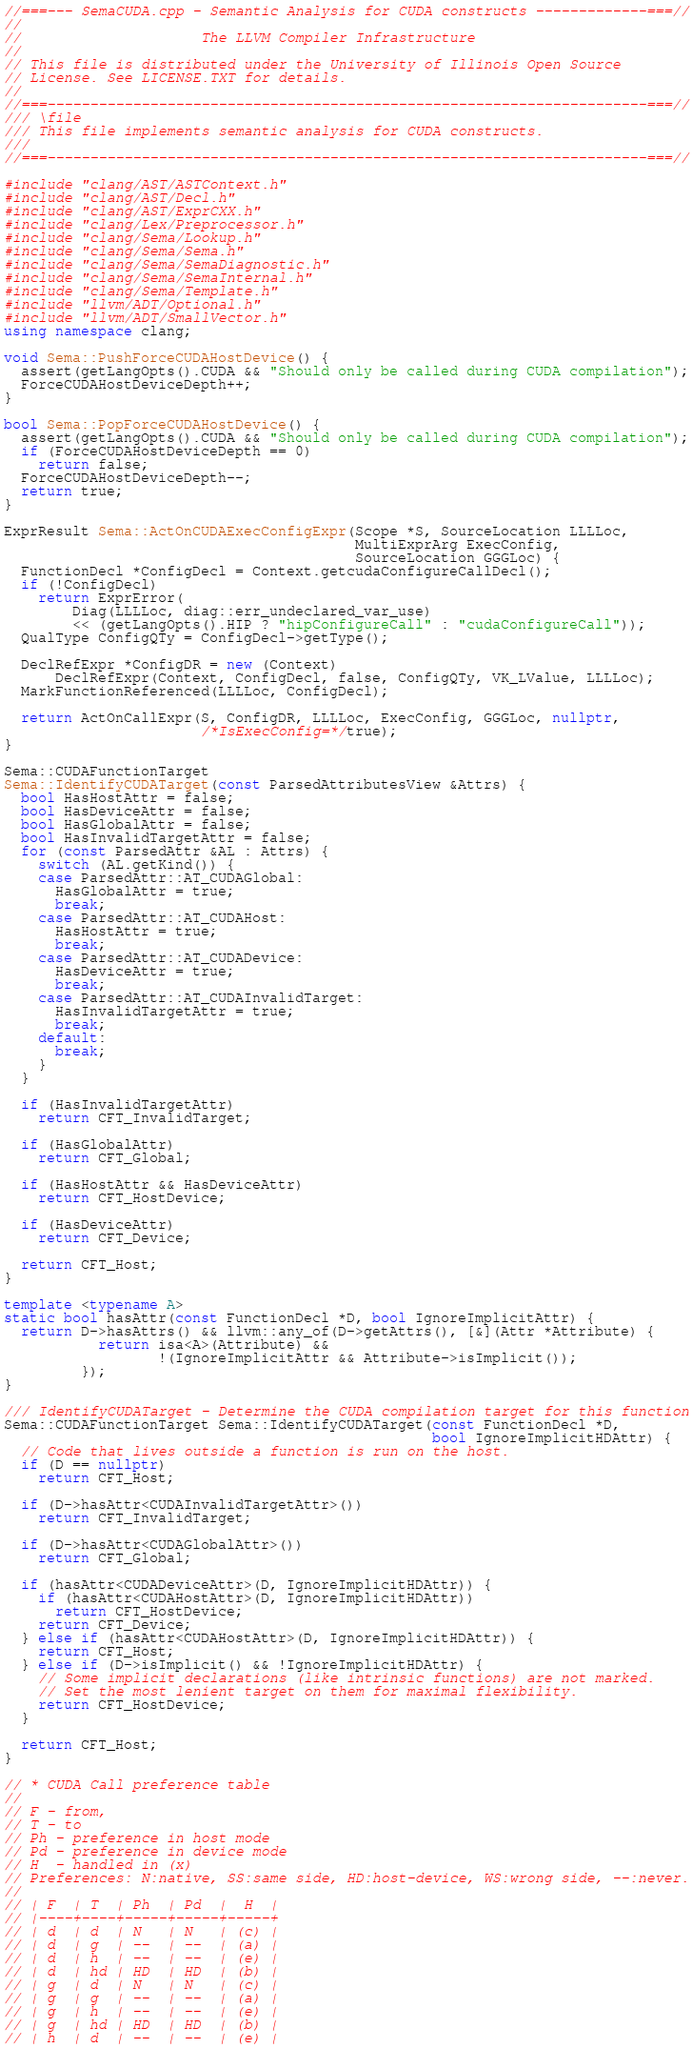<code> <loc_0><loc_0><loc_500><loc_500><_C++_>//===--- SemaCUDA.cpp - Semantic Analysis for CUDA constructs -------------===//
//
//                     The LLVM Compiler Infrastructure
//
// This file is distributed under the University of Illinois Open Source
// License. See LICENSE.TXT for details.
//
//===----------------------------------------------------------------------===//
/// \file
/// This file implements semantic analysis for CUDA constructs.
///
//===----------------------------------------------------------------------===//

#include "clang/AST/ASTContext.h"
#include "clang/AST/Decl.h"
#include "clang/AST/ExprCXX.h"
#include "clang/Lex/Preprocessor.h"
#include "clang/Sema/Lookup.h"
#include "clang/Sema/Sema.h"
#include "clang/Sema/SemaDiagnostic.h"
#include "clang/Sema/SemaInternal.h"
#include "clang/Sema/Template.h"
#include "llvm/ADT/Optional.h"
#include "llvm/ADT/SmallVector.h"
using namespace clang;

void Sema::PushForceCUDAHostDevice() {
  assert(getLangOpts().CUDA && "Should only be called during CUDA compilation");
  ForceCUDAHostDeviceDepth++;
}

bool Sema::PopForceCUDAHostDevice() {
  assert(getLangOpts().CUDA && "Should only be called during CUDA compilation");
  if (ForceCUDAHostDeviceDepth == 0)
    return false;
  ForceCUDAHostDeviceDepth--;
  return true;
}

ExprResult Sema::ActOnCUDAExecConfigExpr(Scope *S, SourceLocation LLLLoc,
                                         MultiExprArg ExecConfig,
                                         SourceLocation GGGLoc) {
  FunctionDecl *ConfigDecl = Context.getcudaConfigureCallDecl();
  if (!ConfigDecl)
    return ExprError(
        Diag(LLLLoc, diag::err_undeclared_var_use)
        << (getLangOpts().HIP ? "hipConfigureCall" : "cudaConfigureCall"));
  QualType ConfigQTy = ConfigDecl->getType();

  DeclRefExpr *ConfigDR = new (Context)
      DeclRefExpr(Context, ConfigDecl, false, ConfigQTy, VK_LValue, LLLLoc);
  MarkFunctionReferenced(LLLLoc, ConfigDecl);

  return ActOnCallExpr(S, ConfigDR, LLLLoc, ExecConfig, GGGLoc, nullptr,
                       /*IsExecConfig=*/true);
}

Sema::CUDAFunctionTarget
Sema::IdentifyCUDATarget(const ParsedAttributesView &Attrs) {
  bool HasHostAttr = false;
  bool HasDeviceAttr = false;
  bool HasGlobalAttr = false;
  bool HasInvalidTargetAttr = false;
  for (const ParsedAttr &AL : Attrs) {
    switch (AL.getKind()) {
    case ParsedAttr::AT_CUDAGlobal:
      HasGlobalAttr = true;
      break;
    case ParsedAttr::AT_CUDAHost:
      HasHostAttr = true;
      break;
    case ParsedAttr::AT_CUDADevice:
      HasDeviceAttr = true;
      break;
    case ParsedAttr::AT_CUDAInvalidTarget:
      HasInvalidTargetAttr = true;
      break;
    default:
      break;
    }
  }

  if (HasInvalidTargetAttr)
    return CFT_InvalidTarget;

  if (HasGlobalAttr)
    return CFT_Global;

  if (HasHostAttr && HasDeviceAttr)
    return CFT_HostDevice;

  if (HasDeviceAttr)
    return CFT_Device;

  return CFT_Host;
}

template <typename A>
static bool hasAttr(const FunctionDecl *D, bool IgnoreImplicitAttr) {
  return D->hasAttrs() && llvm::any_of(D->getAttrs(), [&](Attr *Attribute) {
           return isa<A>(Attribute) &&
                  !(IgnoreImplicitAttr && Attribute->isImplicit());
         });
}

/// IdentifyCUDATarget - Determine the CUDA compilation target for this function
Sema::CUDAFunctionTarget Sema::IdentifyCUDATarget(const FunctionDecl *D,
                                                  bool IgnoreImplicitHDAttr) {
  // Code that lives outside a function is run on the host.
  if (D == nullptr)
    return CFT_Host;

  if (D->hasAttr<CUDAInvalidTargetAttr>())
    return CFT_InvalidTarget;

  if (D->hasAttr<CUDAGlobalAttr>())
    return CFT_Global;

  if (hasAttr<CUDADeviceAttr>(D, IgnoreImplicitHDAttr)) {
    if (hasAttr<CUDAHostAttr>(D, IgnoreImplicitHDAttr))
      return CFT_HostDevice;
    return CFT_Device;
  } else if (hasAttr<CUDAHostAttr>(D, IgnoreImplicitHDAttr)) {
    return CFT_Host;
  } else if (D->isImplicit() && !IgnoreImplicitHDAttr) {
    // Some implicit declarations (like intrinsic functions) are not marked.
    // Set the most lenient target on them for maximal flexibility.
    return CFT_HostDevice;
  }

  return CFT_Host;
}

// * CUDA Call preference table
//
// F - from,
// T - to
// Ph - preference in host mode
// Pd - preference in device mode
// H  - handled in (x)
// Preferences: N:native, SS:same side, HD:host-device, WS:wrong side, --:never.
//
// | F  | T  | Ph  | Pd  |  H  |
// |----+----+-----+-----+-----+
// | d  | d  | N   | N   | (c) |
// | d  | g  | --  | --  | (a) |
// | d  | h  | --  | --  | (e) |
// | d  | hd | HD  | HD  | (b) |
// | g  | d  | N   | N   | (c) |
// | g  | g  | --  | --  | (a) |
// | g  | h  | --  | --  | (e) |
// | g  | hd | HD  | HD  | (b) |
// | h  | d  | --  | --  | (e) |</code> 